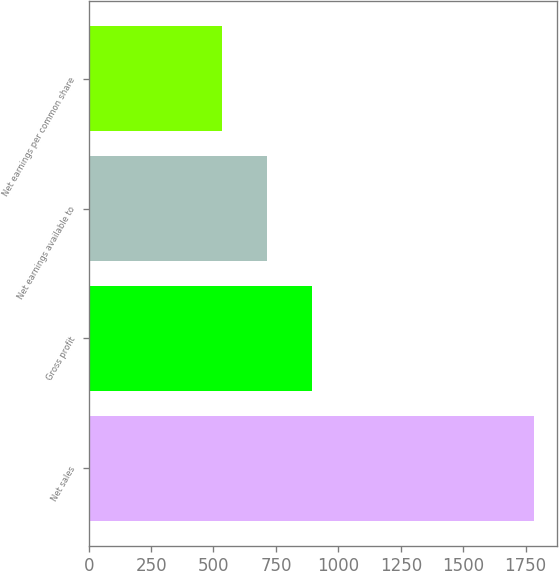Convert chart to OTSL. <chart><loc_0><loc_0><loc_500><loc_500><bar_chart><fcel>Net sales<fcel>Gross profit<fcel>Net earnings available to<fcel>Net earnings per common share<nl><fcel>1785<fcel>892.58<fcel>714.09<fcel>535.6<nl></chart> 